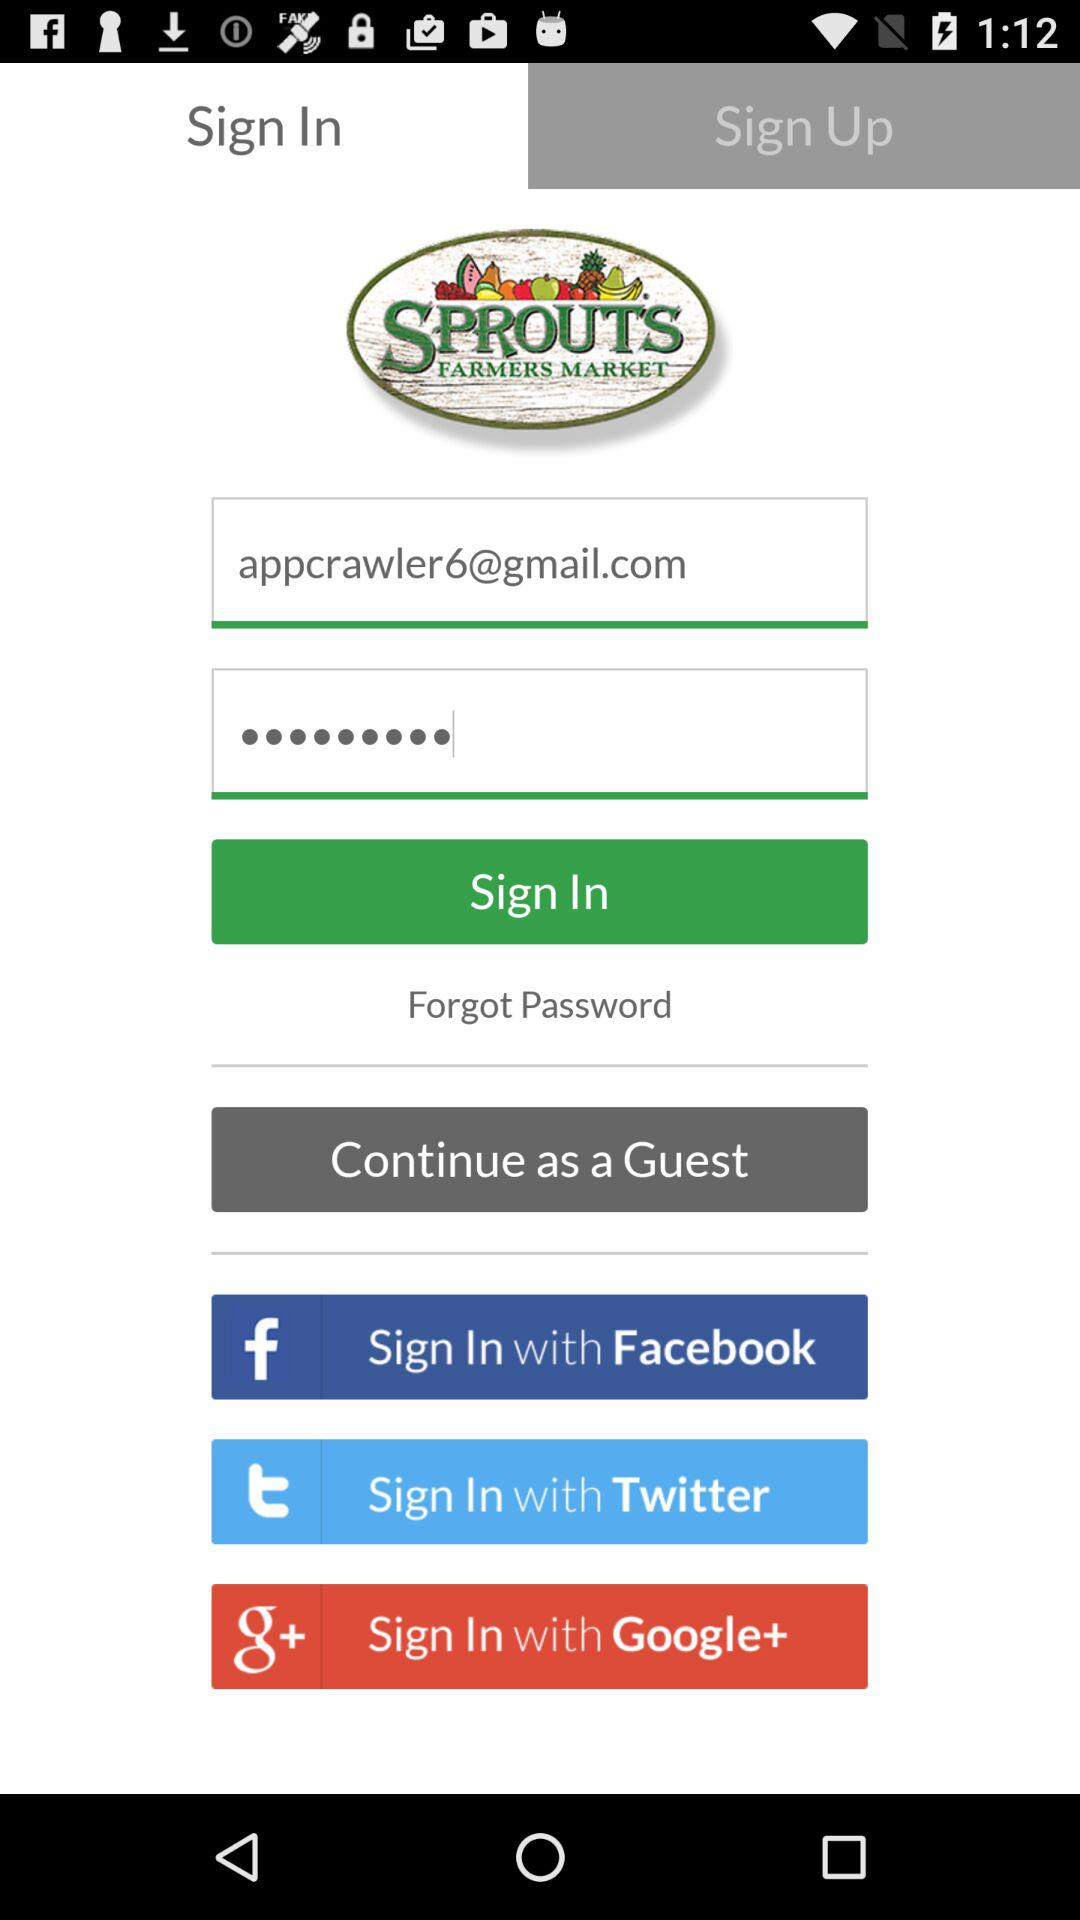What is the application name? The application name is "Sprouts". 